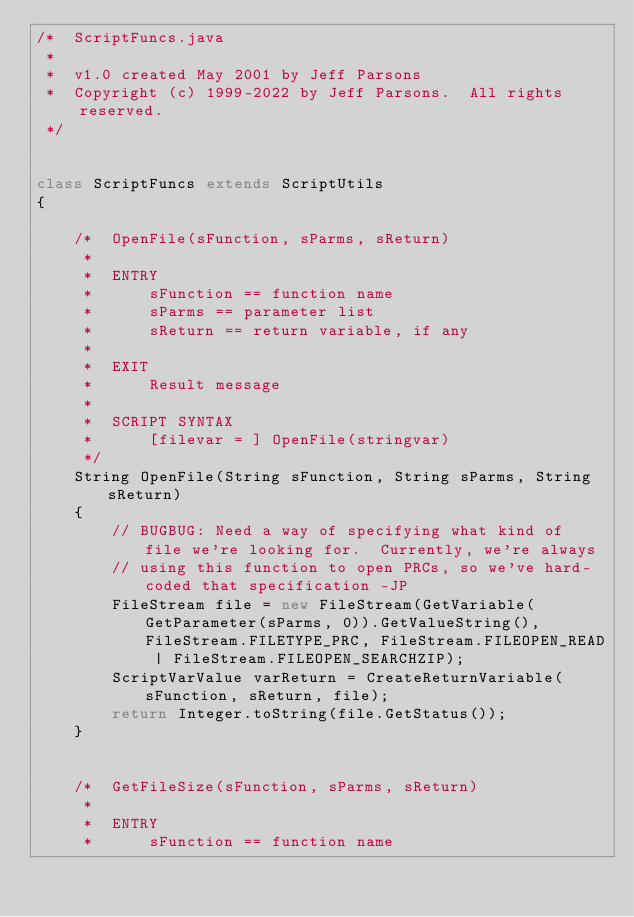<code> <loc_0><loc_0><loc_500><loc_500><_Java_>/*  ScriptFuncs.java
 *
 *  v1.0 created May 2001 by Jeff Parsons
 *  Copyright (c) 1999-2022 by Jeff Parsons.  All rights reserved.
 */


class ScriptFuncs extends ScriptUtils
{
    
    /*  OpenFile(sFunction, sParms, sReturn)
     *
     *  ENTRY
     *      sFunction == function name
     *      sParms == parameter list
     *      sReturn == return variable, if any
     *
     *  EXIT
     *      Result message
     *
     *  SCRIPT SYNTAX
     *      [filevar = ] OpenFile(stringvar)
     */
    String OpenFile(String sFunction, String sParms, String sReturn)
    {
        // BUGBUG: Need a way of specifying what kind of file we're looking for.  Currently, we're always
        // using this function to open PRCs, so we've hard-coded that specification -JP
        FileStream file = new FileStream(GetVariable(GetParameter(sParms, 0)).GetValueString(), FileStream.FILETYPE_PRC, FileStream.FILEOPEN_READ | FileStream.FILEOPEN_SEARCHZIP);
        ScriptVarValue varReturn = CreateReturnVariable(sFunction, sReturn, file);
        return Integer.toString(file.GetStatus());
    }
        

    /*  GetFileSize(sFunction, sParms, sReturn)
     *
     *  ENTRY
     *      sFunction == function name</code> 